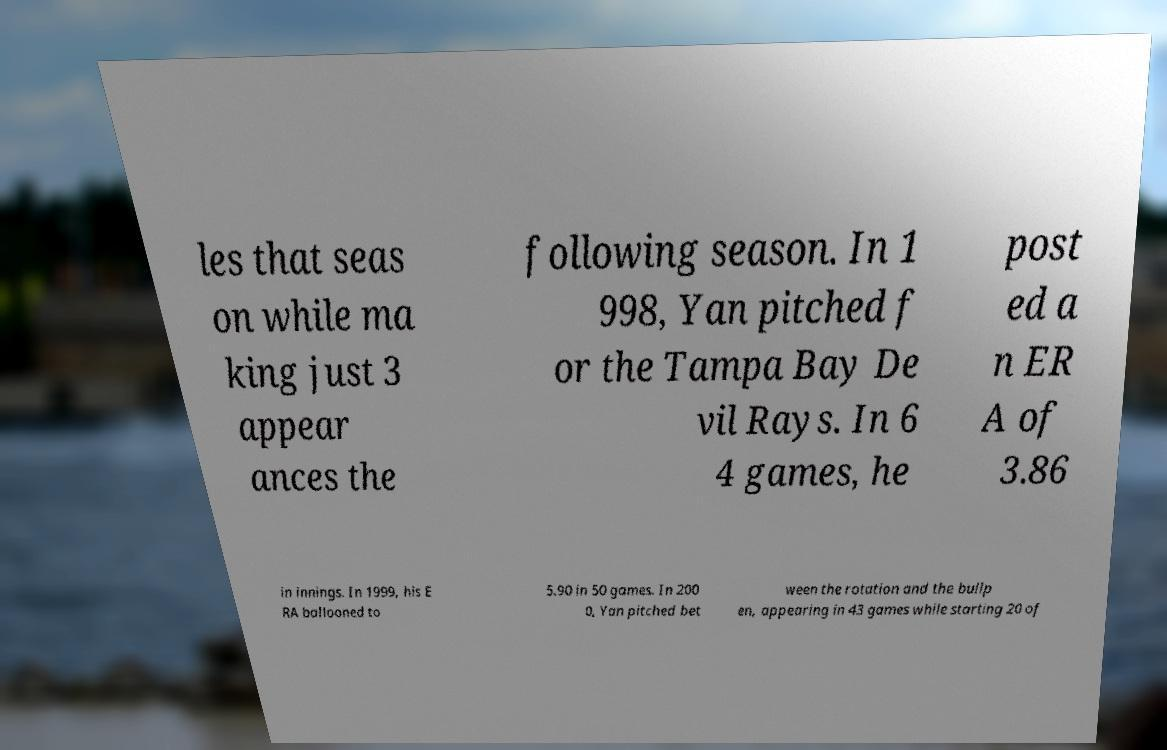Can you accurately transcribe the text from the provided image for me? les that seas on while ma king just 3 appear ances the following season. In 1 998, Yan pitched f or the Tampa Bay De vil Rays. In 6 4 games, he post ed a n ER A of 3.86 in innings. In 1999, his E RA ballooned to 5.90 in 50 games. In 200 0, Yan pitched bet ween the rotation and the bullp en, appearing in 43 games while starting 20 of 